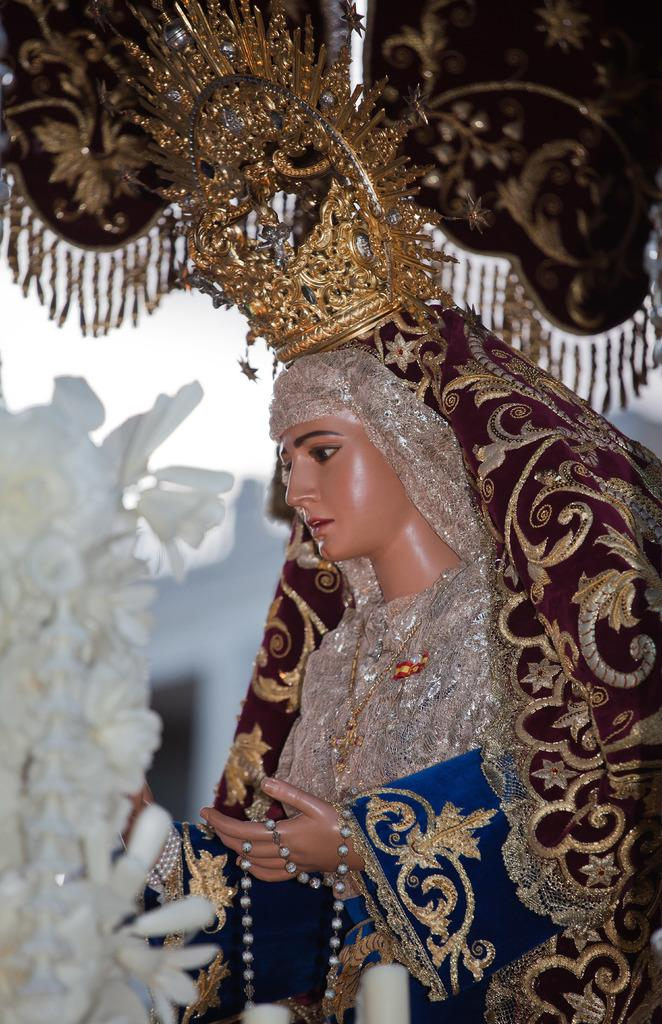What is the main subject of the image? There is a statue in the image. What is the statue wearing on its head? The statue is wearing a crown. What color is the dress worn by the statue? The statue is wearing a blue dress. What can be seen on the left side of the image? There are flowers on the left side of the image. What type of orange is being played by the owl in the image? There is no owl or orange present in the image. 